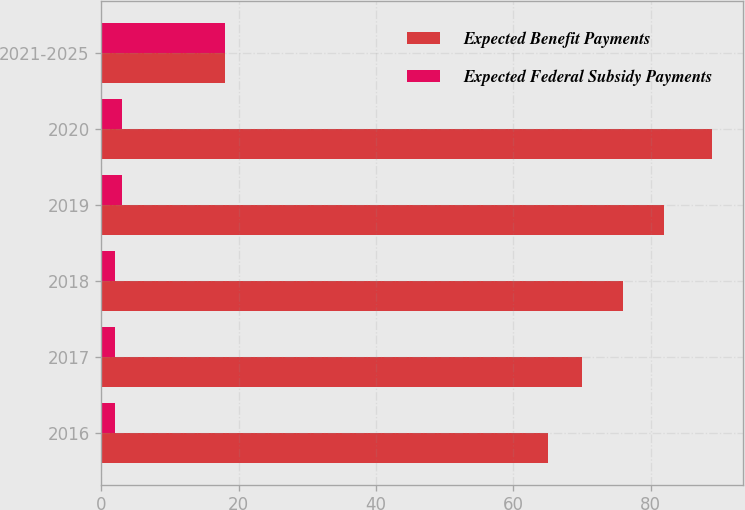Convert chart. <chart><loc_0><loc_0><loc_500><loc_500><stacked_bar_chart><ecel><fcel>2016<fcel>2017<fcel>2018<fcel>2019<fcel>2020<fcel>2021-2025<nl><fcel>Expected Benefit Payments<fcel>65<fcel>70<fcel>76<fcel>82<fcel>89<fcel>18<nl><fcel>Expected Federal Subsidy Payments<fcel>2<fcel>2<fcel>2<fcel>3<fcel>3<fcel>18<nl></chart> 